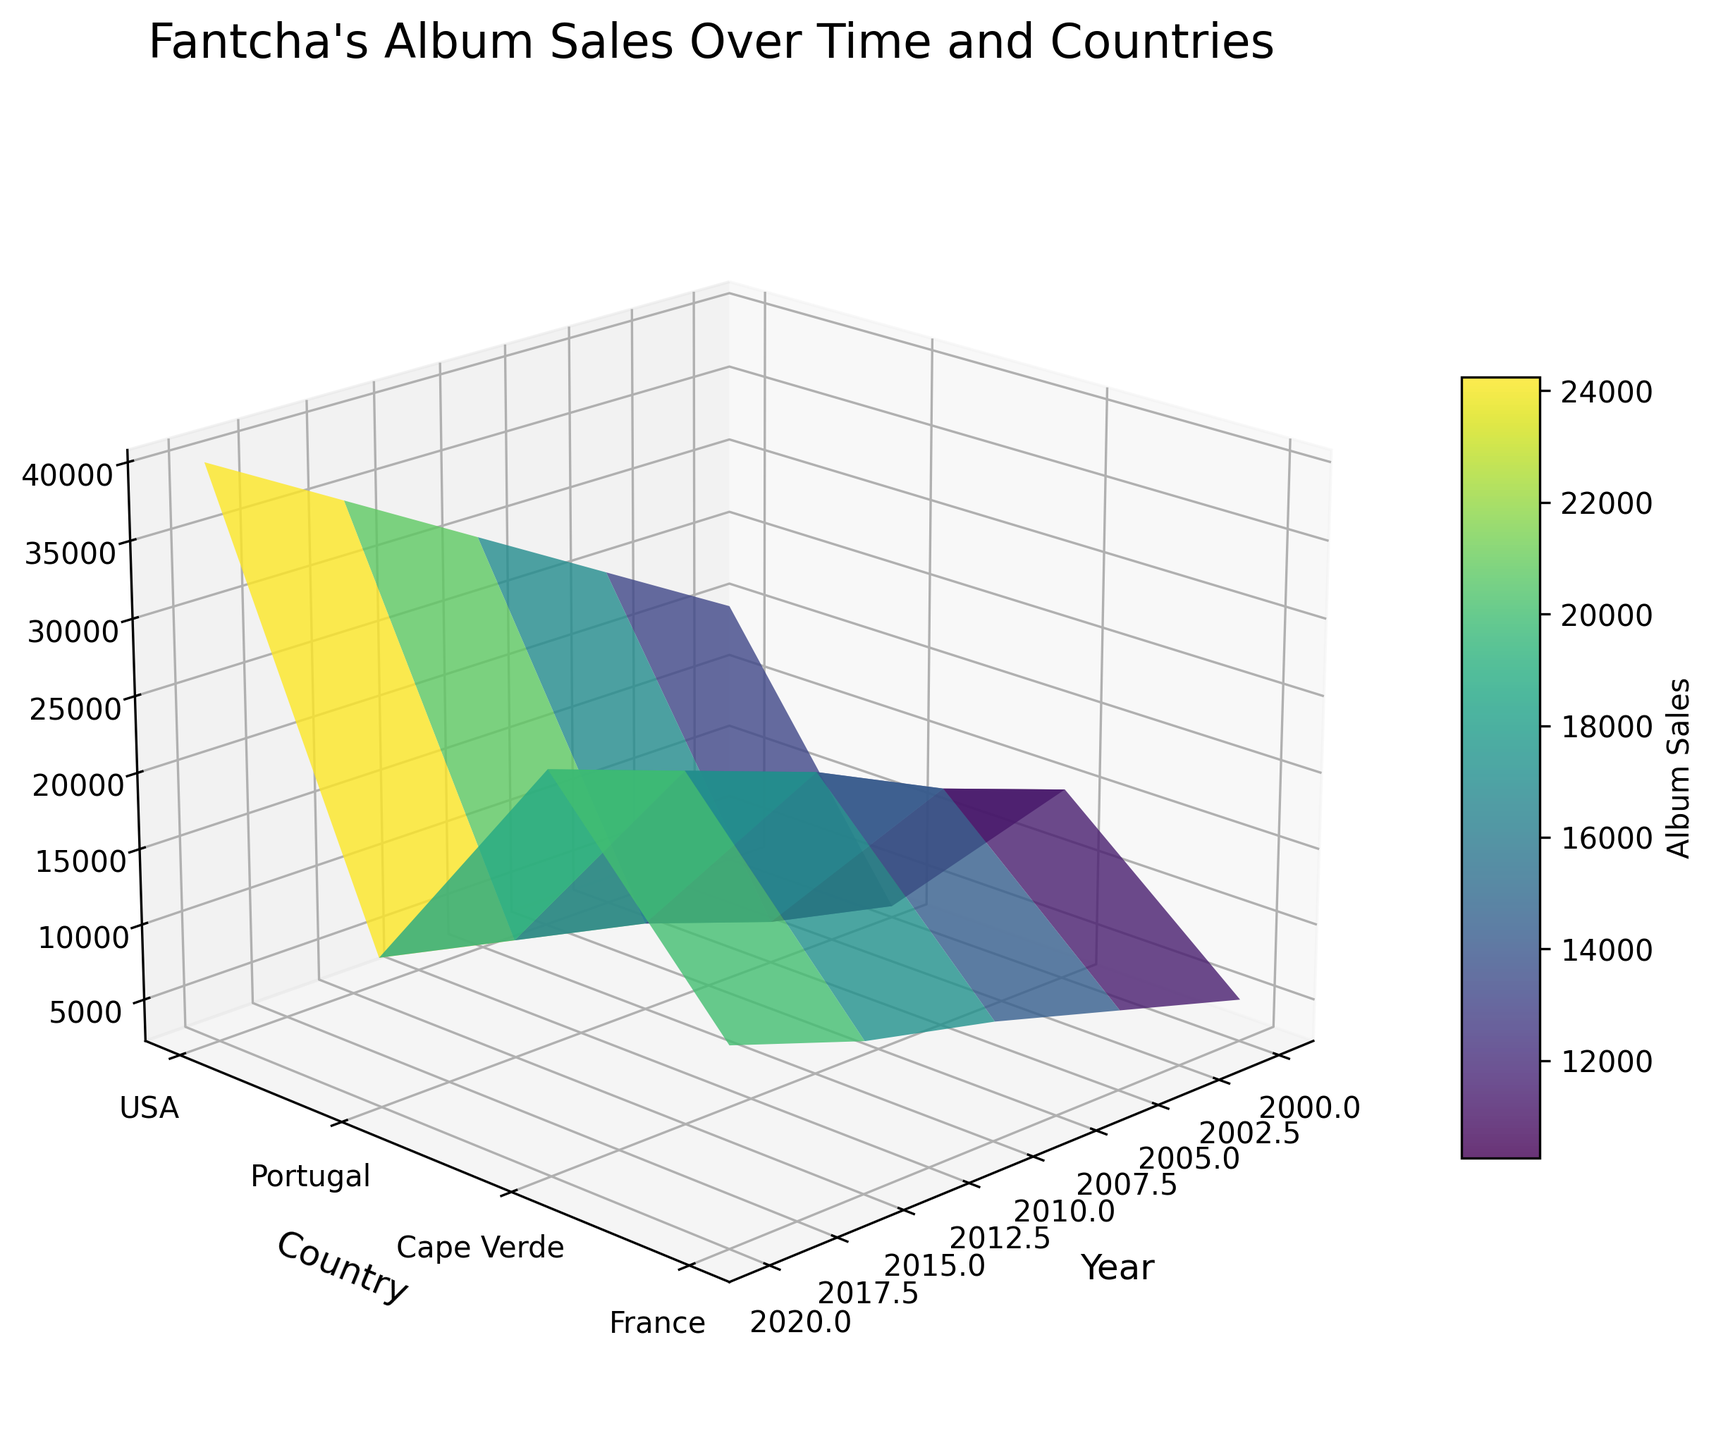What is the title of the 3D surface plot? The title is often located at the top of the plot. In this case, the title is "Fantcha's Album Sales Over Time and Countries."
Answer: Fantcha's Album Sales Over Time and Countries Which year has the highest album sales in Cape Verde? To find this, look at the peak points in the `Z` axis that correspond to Cape Verde on the `Y` axis. The highest point for Cape Verde is around the year 2020.
Answer: 2020 How do album sales in the USA in 2015 compare to those in Portugal in 2015? Identify the `Z` values for the USA and Portugal in the year 2015. The plot reveals that the album sales in the USA are lower than those in Portugal for 2015.
Answer: Lower What is the trend in album sales in France from 2000 to 2020? To determine the trend, follow the `Z` values along the `X` axis for France on the `Y` axis. The trend is increasing, as the sales go from 3000 in 2000 to 12000 in 2020.
Answer: Increasing Which country had the highest album sales in 2010? Look at the `Z` values for all countries in the specified year. In 2010, Cape Verde has the highest album sales.
Answer: Cape Verde Comparing album sales in 2005 and 2015, which year had higher sales on average across all countries? Calculate average sales by adding up the `Z` values for each year and divide by the number of countries. For 2005, (7500 + 18000 + 25000 + 5000) = 55500. For 2015, (12000 + 25000 + 35000 + 10000) = 82000. Calculating the average, we get: 55500/4 = 13875, and 82000/4 = 20500.
Answer: 2015 How do album sales in Cape Verde compare to Portugal from 2000 to 2020? Look at the ‘Z’ values over the `X` axis for Cape Verde and Portugal on the `Y` axis from 2000 to 2020. Cape Verde consistently has higher sales than Portugal in all the given years.
Answer: Higher What is the average album sales in the USA over the specified period? Sum up the `Z` values for the USA from 2000 to 2020 and divide by the number of years. Total USA sales: (5000 + 7500 + 10000 + 12000 + 15000) = 49500. Number of years = 5. Calculating the average, 49500/5 = 9900.
Answer: 9900 In which year do we see the sharpest increase in album sales for Portugal? Compare the increase between years by following the `Z` values along the `X` axis for Portugal on the `Y` axis. The sharpest increase is between 2005 (18000) and 2010 (22000), which is an increase of 4000.
Answer: 2005 to 2010 